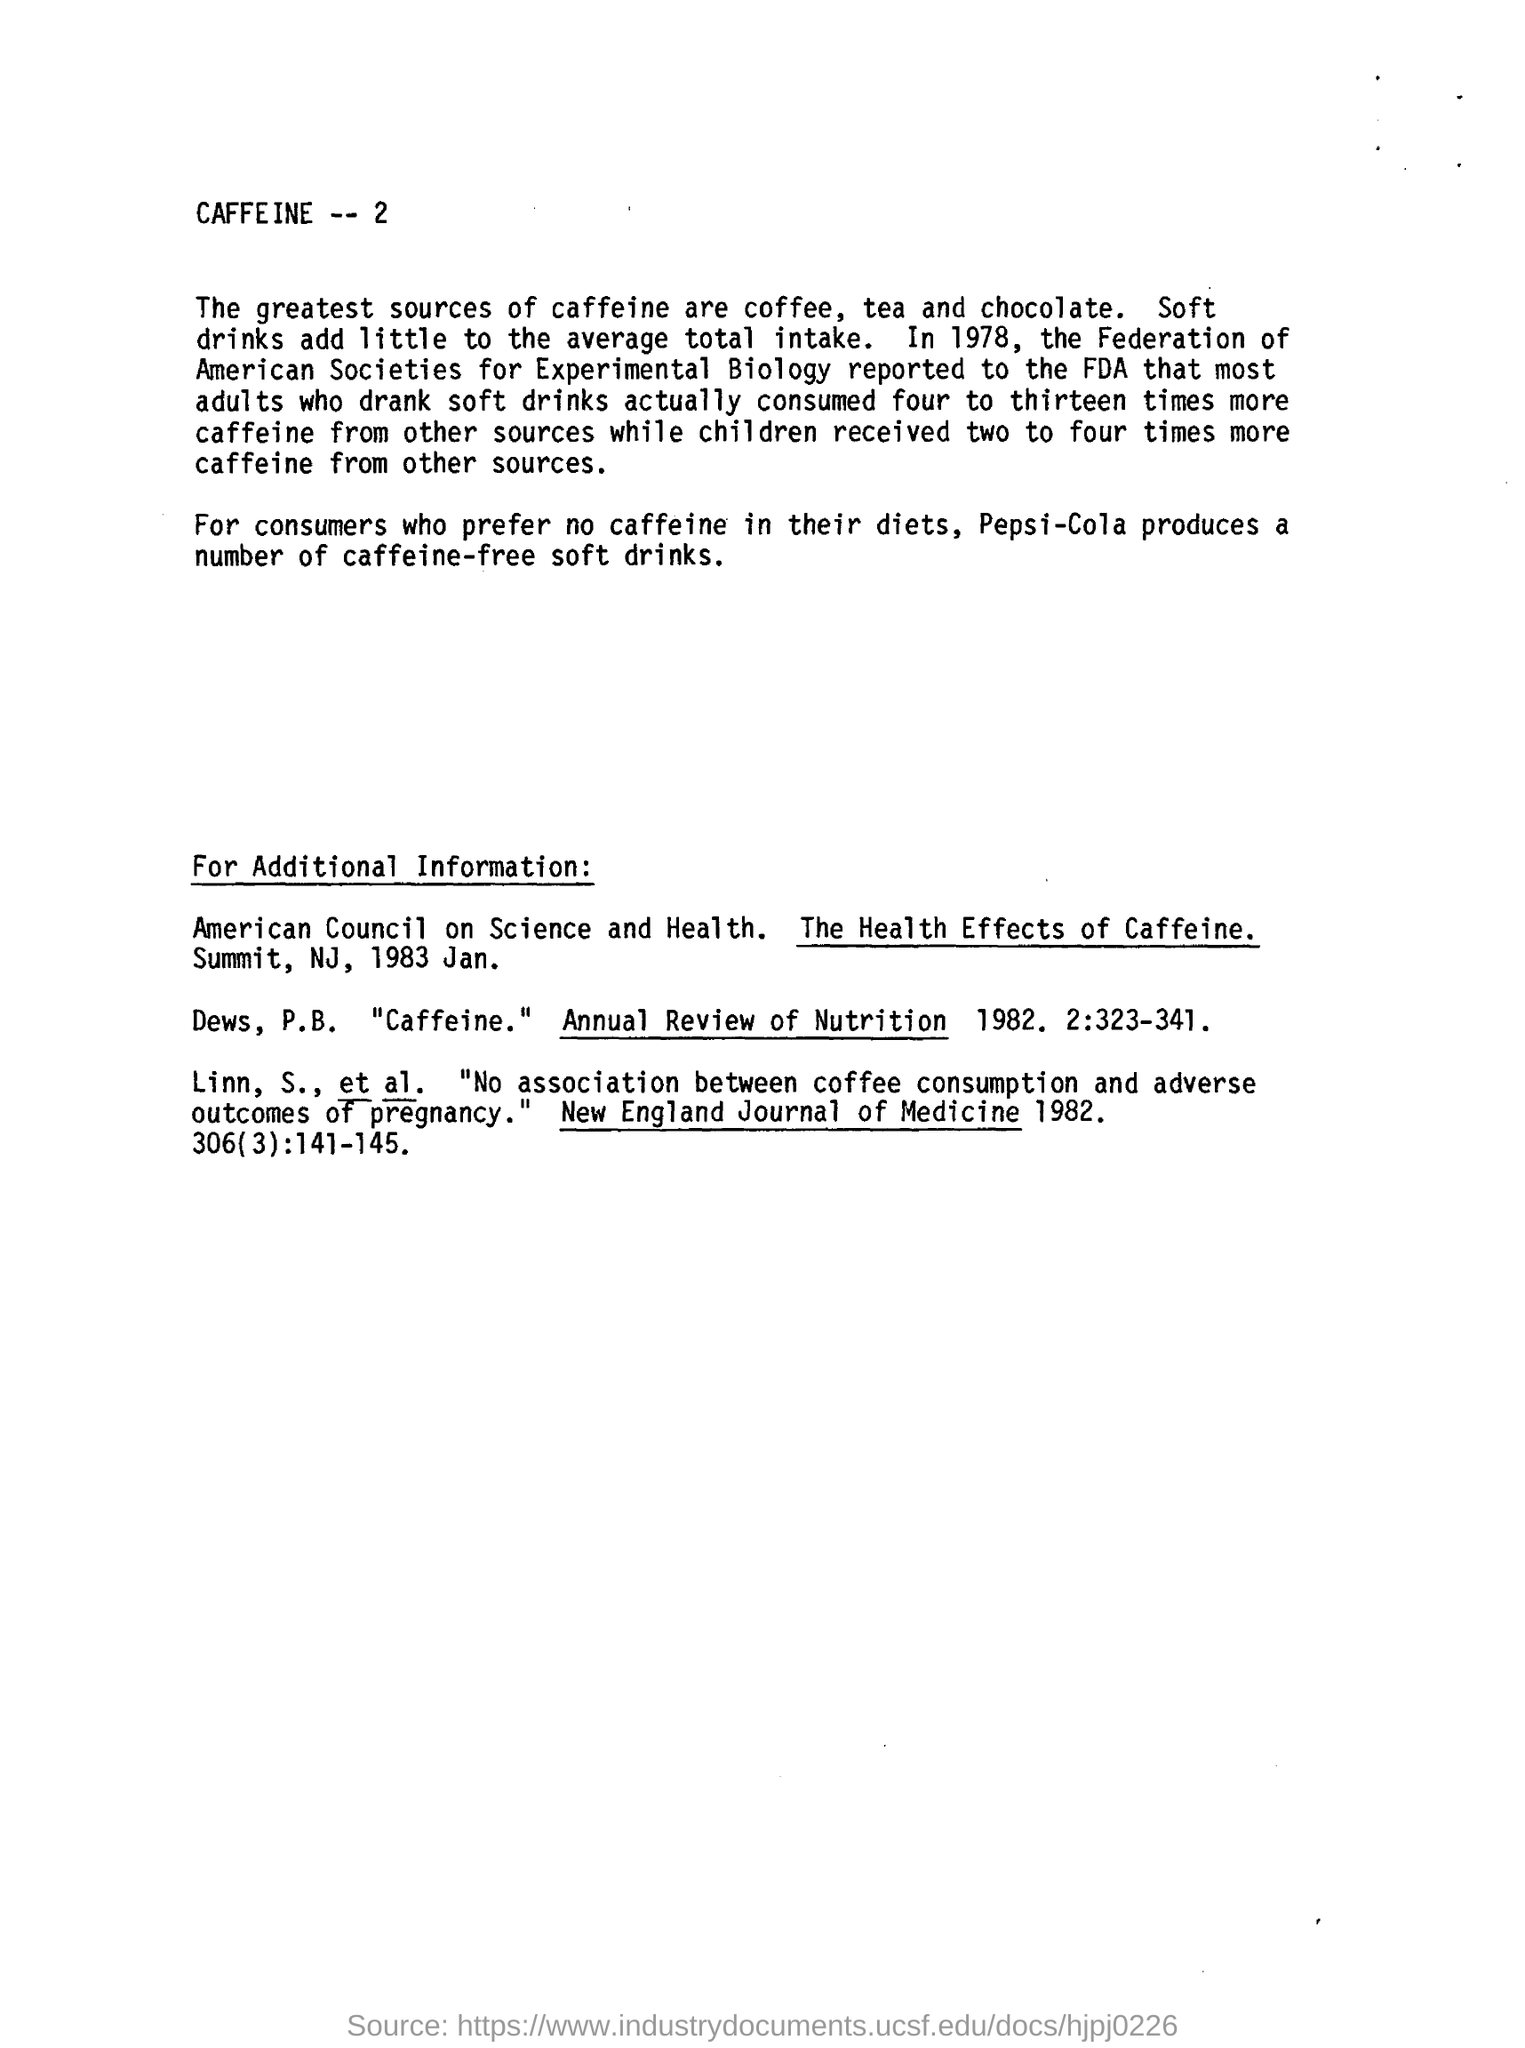What are some common soft drinks that people might not realize contain caffeine? Many people may be surprised to learn that in addition to the obvious caffeinated colas, several other soft drinks contain caffeine. These can include some types of root beer, cream soda, and citrus-flavored sodas. Even some 'energy' or 'enhanced' water products have added caffeine. It's important for consumers to check the labels of their beverages if they're looking to monitor or limit their caffeine intake. 